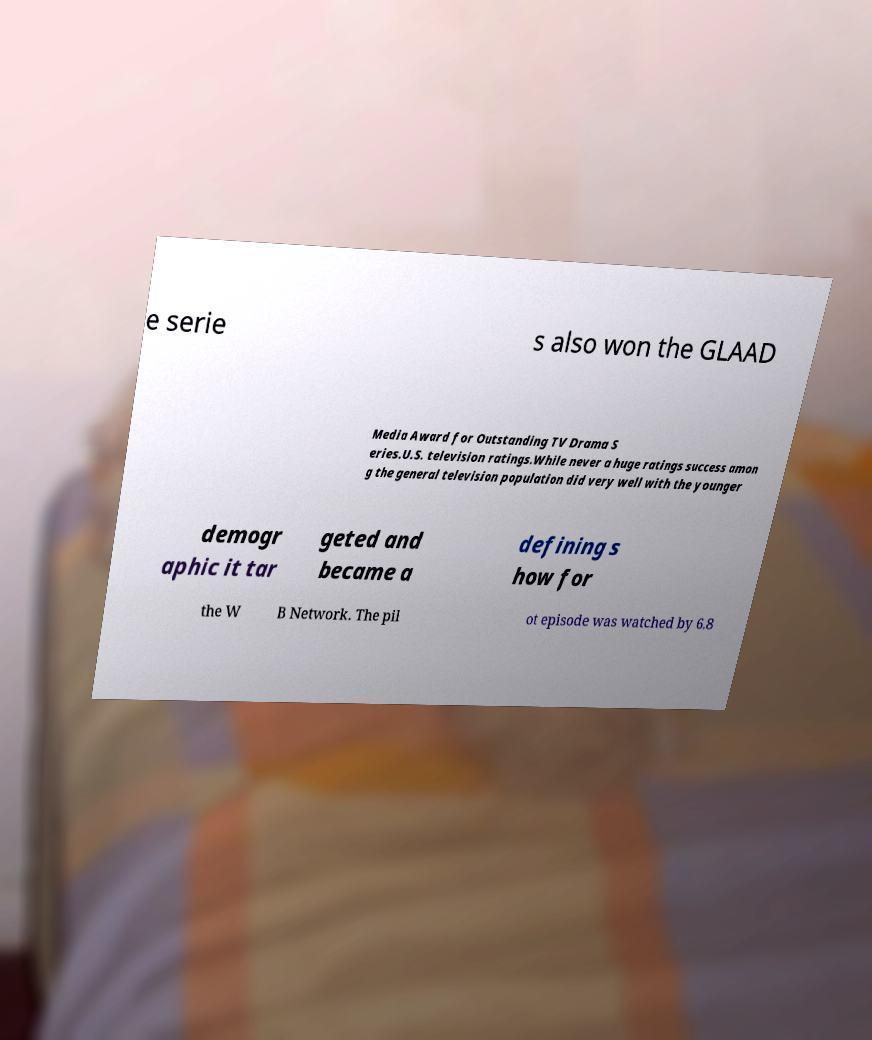What messages or text are displayed in this image? I need them in a readable, typed format. e serie s also won the GLAAD Media Award for Outstanding TV Drama S eries.U.S. television ratings.While never a huge ratings success amon g the general television population did very well with the younger demogr aphic it tar geted and became a defining s how for the W B Network. The pil ot episode was watched by 6.8 